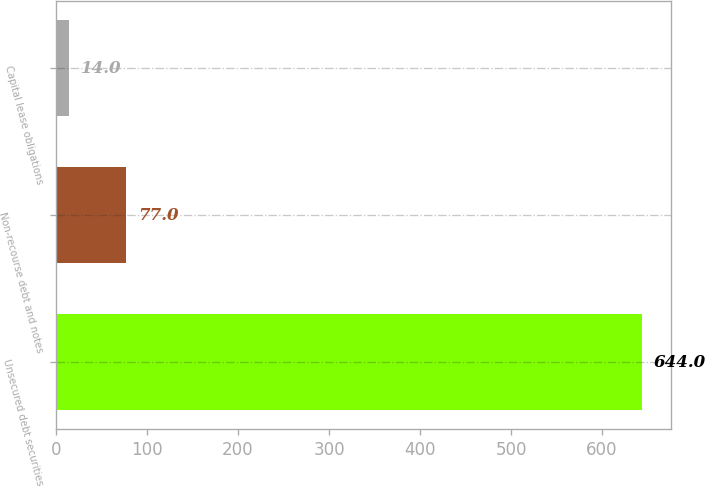Convert chart to OTSL. <chart><loc_0><loc_0><loc_500><loc_500><bar_chart><fcel>Unsecured debt securities<fcel>Non-recourse debt and notes<fcel>Capital lease obligations<nl><fcel>644<fcel>77<fcel>14<nl></chart> 